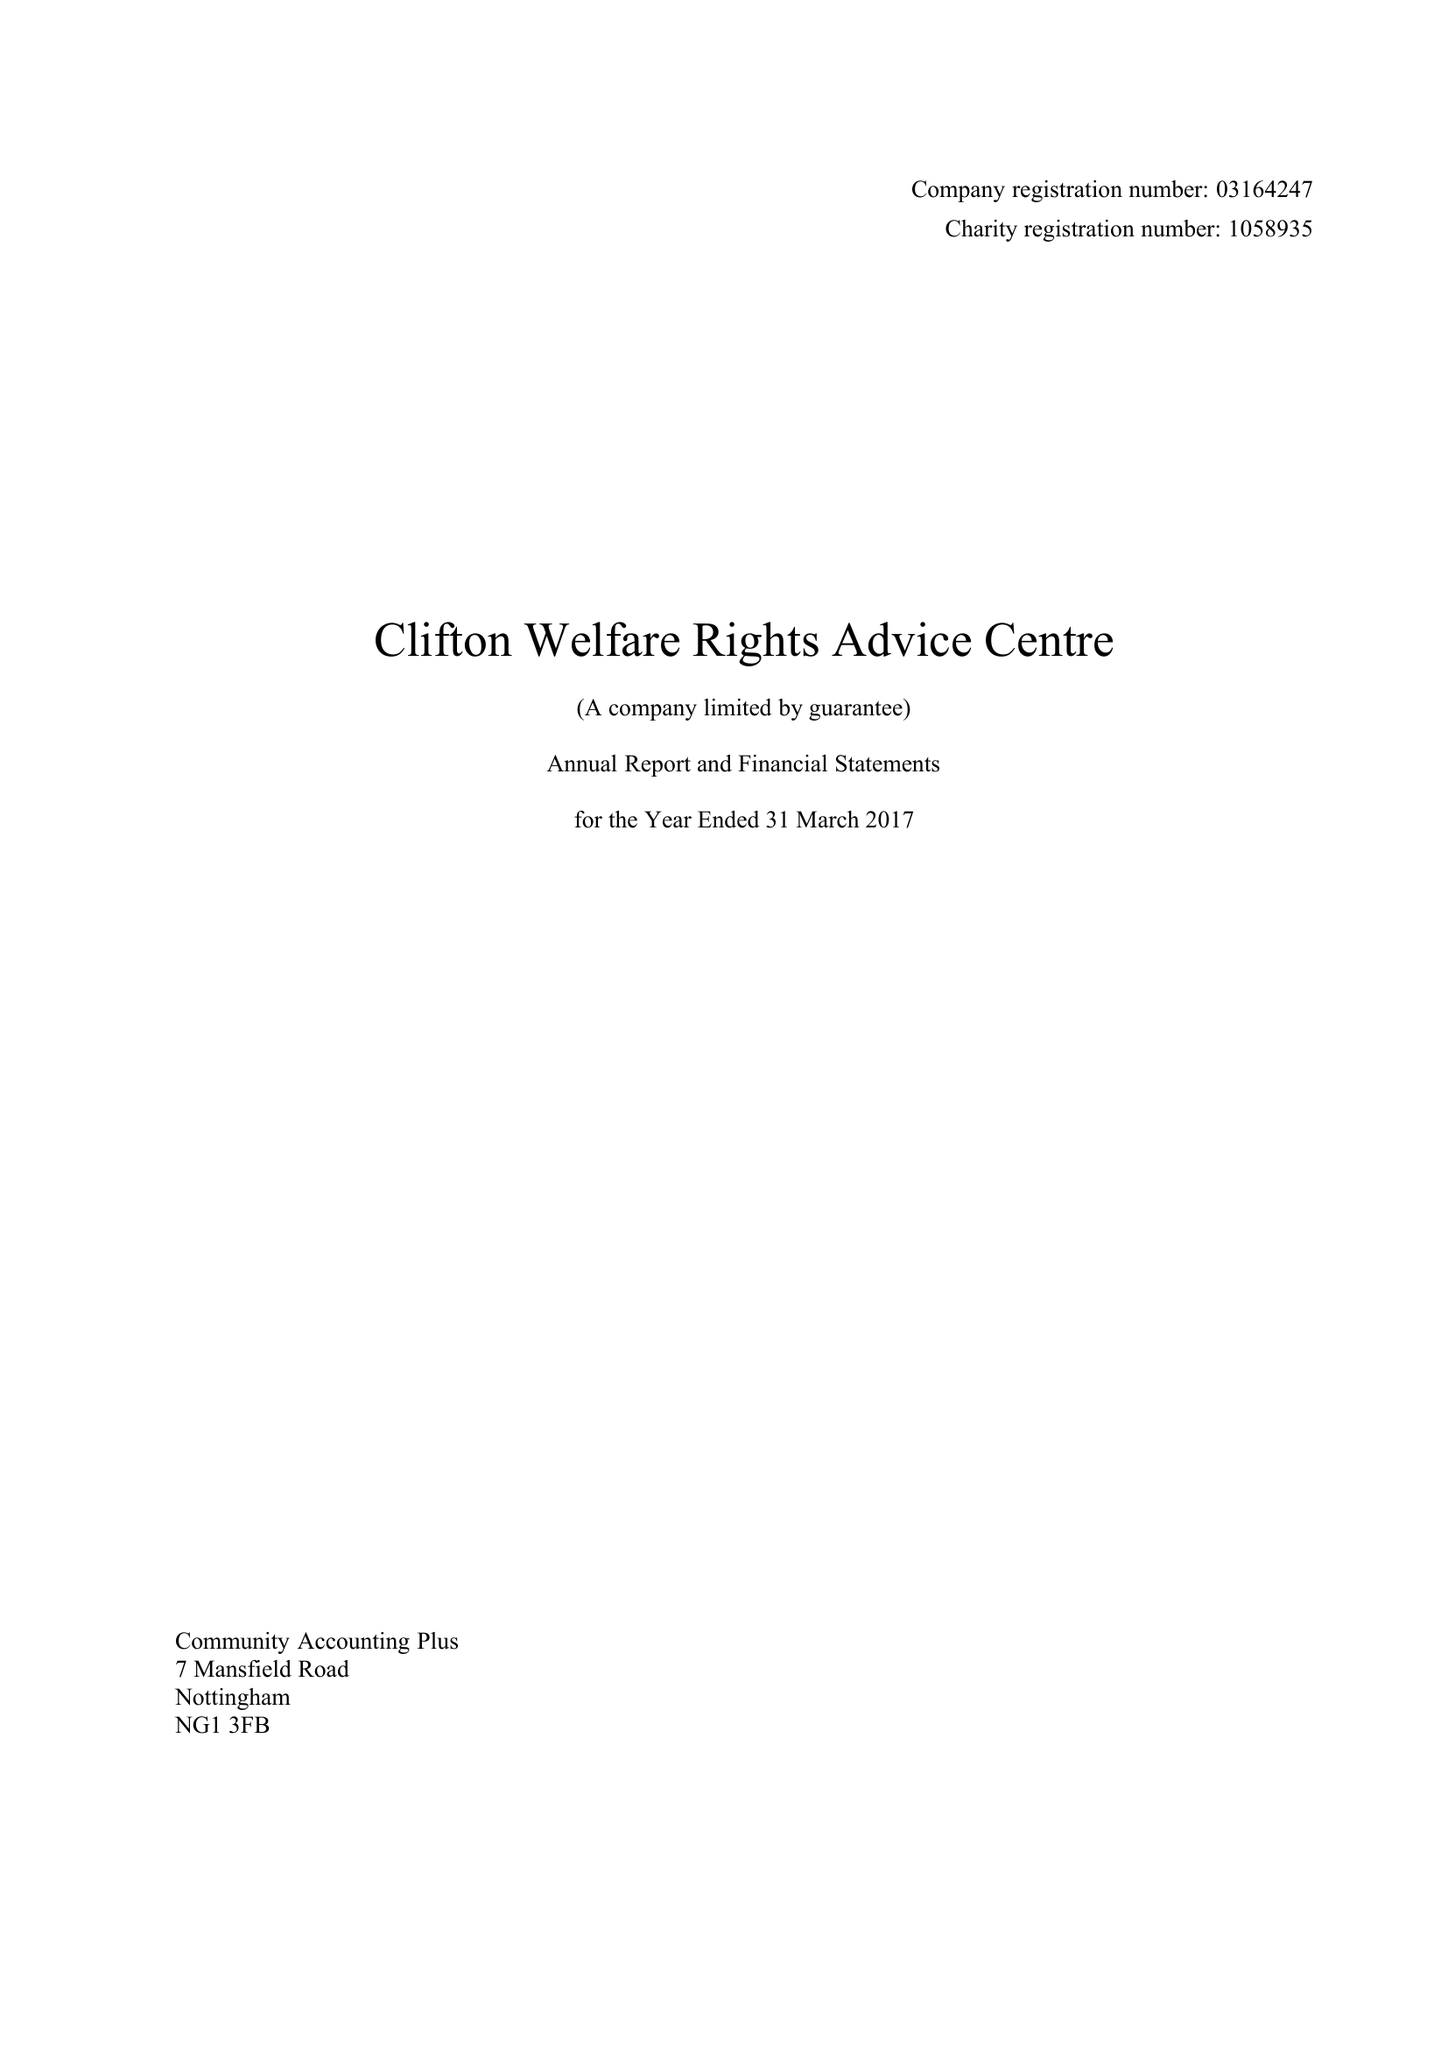What is the value for the spending_annually_in_british_pounds?
Answer the question using a single word or phrase. 86972.00 